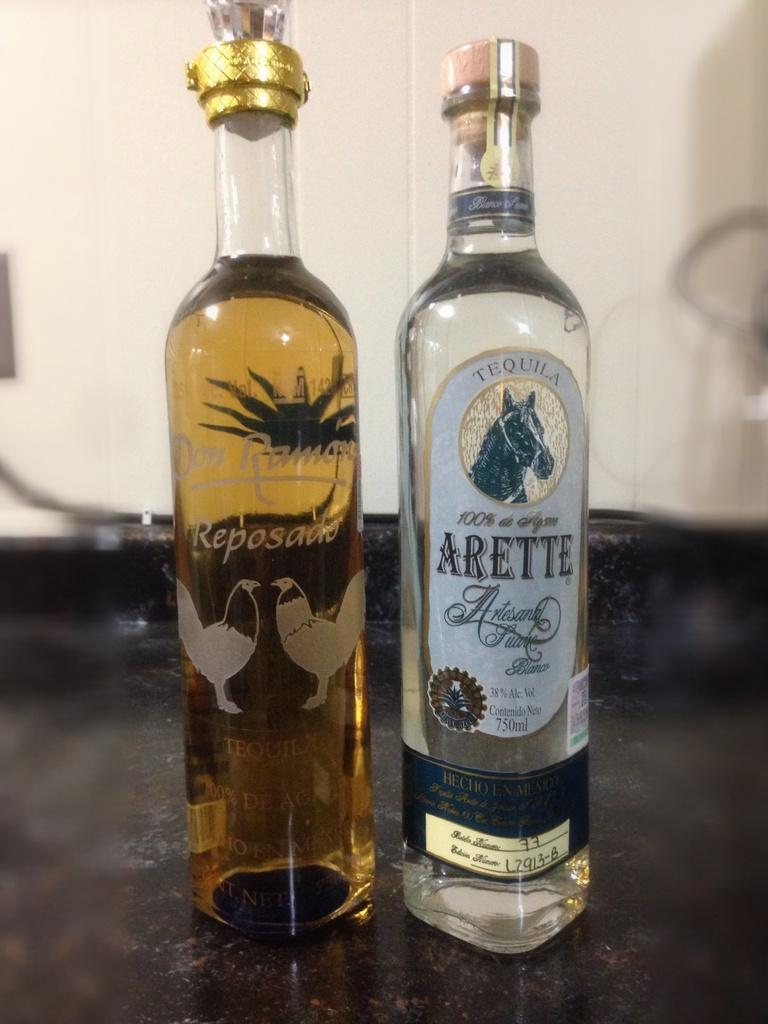What kind of alcohol is in the clear bottle?
Your answer should be compact. Tequila. What is the brand of the right bottle?
Offer a terse response. Arette. 